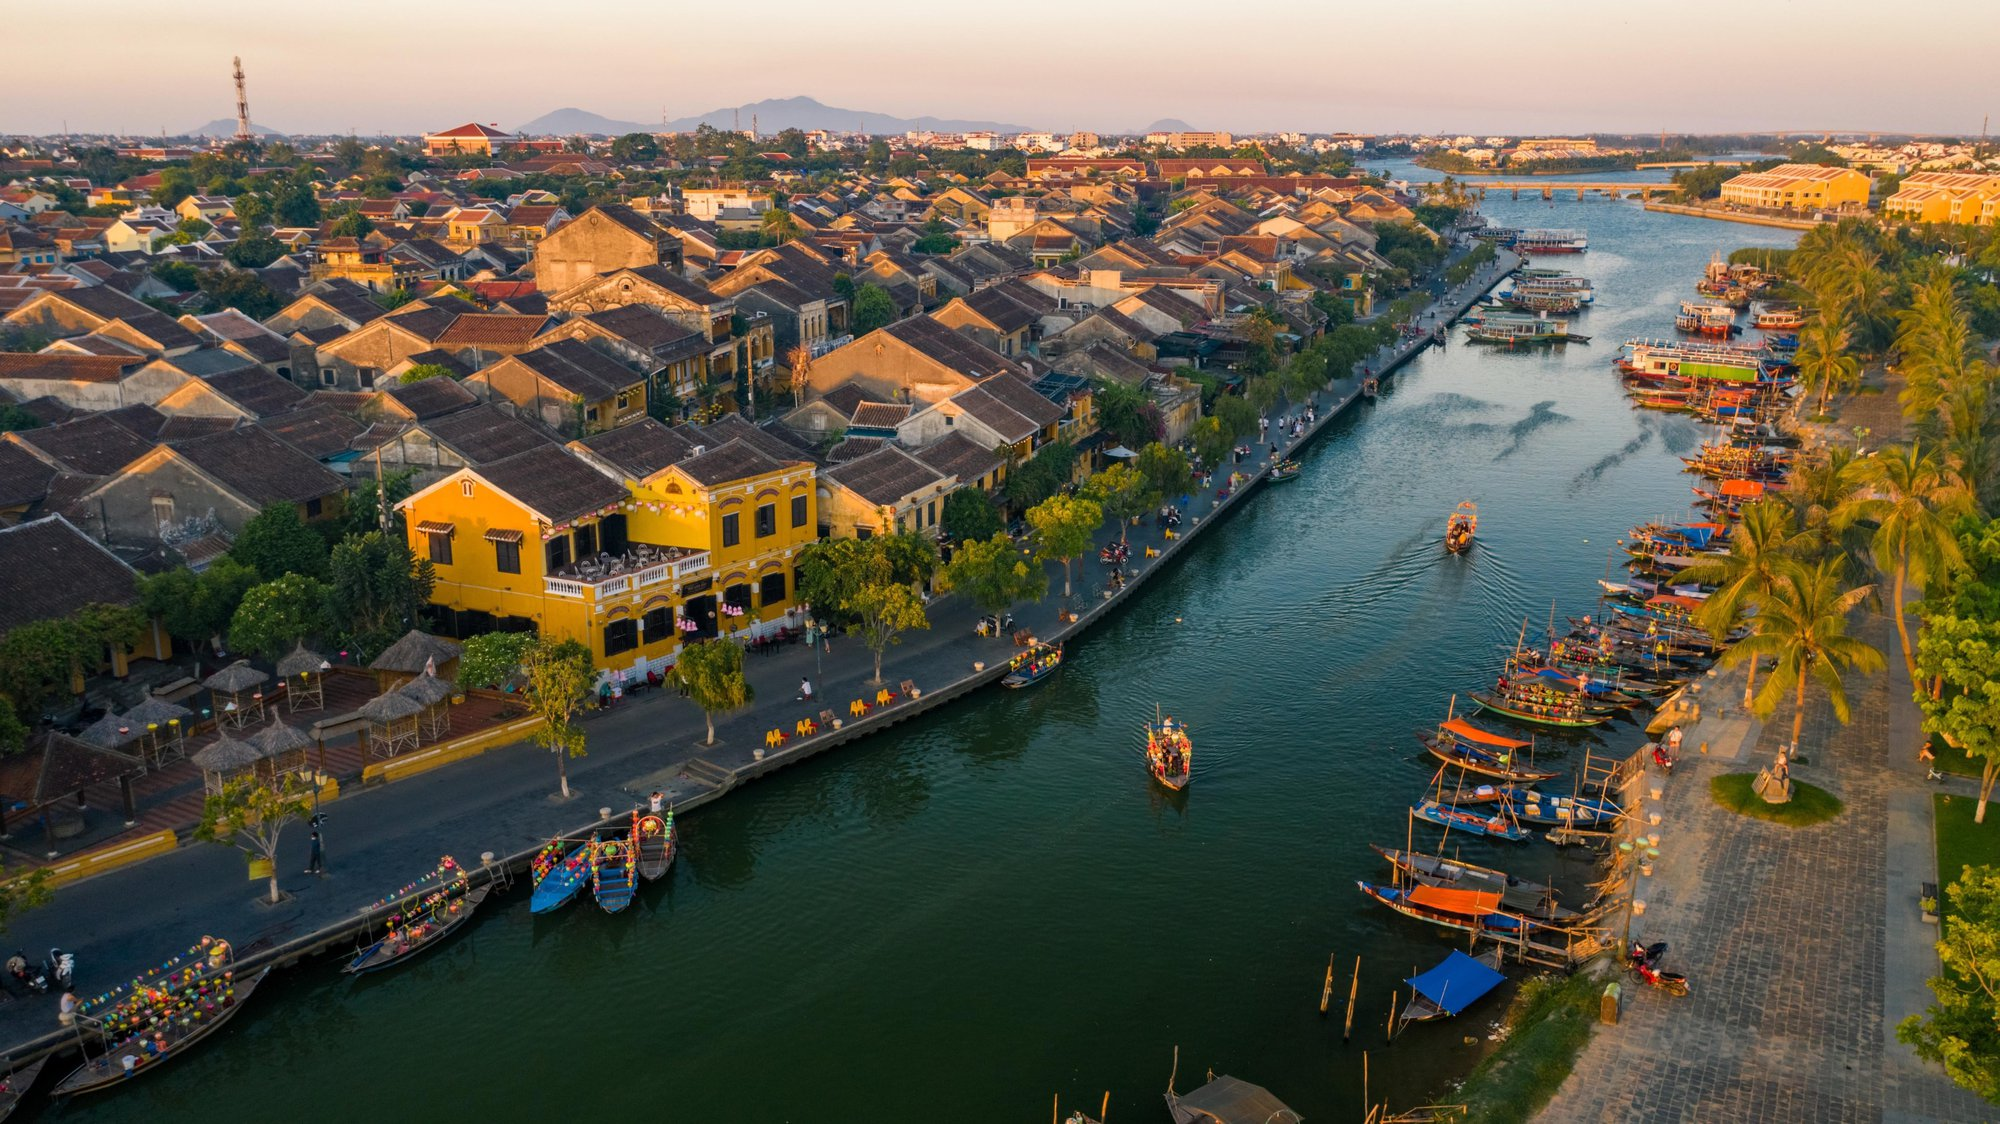If the boats in the image could talk, what stories might they tell? If the boats in the image could talk, they would recount tales of countless sunrises seen over the gentle ripples of the Thu Bon River. They would tell stories of the vibrant festivals, where they were decorated with brilliant lanterns and floated in graceful parades, reflecting the joy and traditions of the local people. They would share memories of quiet early mornings, ferrying fishermen to their favorite spots, and moonlit cruises carrying enchanted tourists. They would speak of solace and companionship with the river, bearing witness to both the triumphs and struggles of the community: times of celebration, times of hardship, and the ever-present resilience of the people who live by the water. Tales of laughter from children enjoying simple joyrides, shared secrets between lovers admiring the starlit sky, and the silent moments when the river spoke volumes in its gentle whispers. Each boat, a storyteller in its own right, holding the essence of life on the Thu Bon River. 